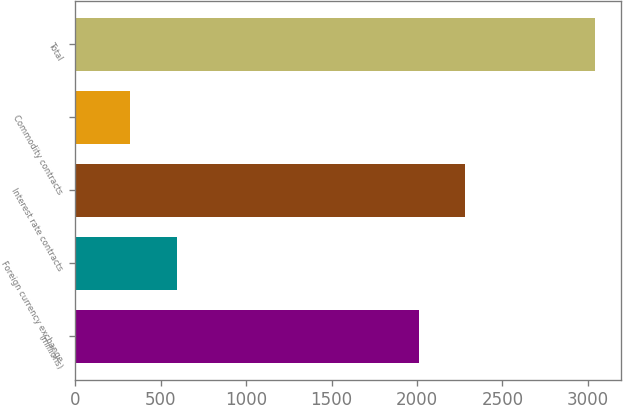Convert chart. <chart><loc_0><loc_0><loc_500><loc_500><bar_chart><fcel>(millions)<fcel>Foreign currency exchange<fcel>Interest rate contracts<fcel>Commodity contracts<fcel>Total<nl><fcel>2012<fcel>592<fcel>2284<fcel>320<fcel>3040<nl></chart> 